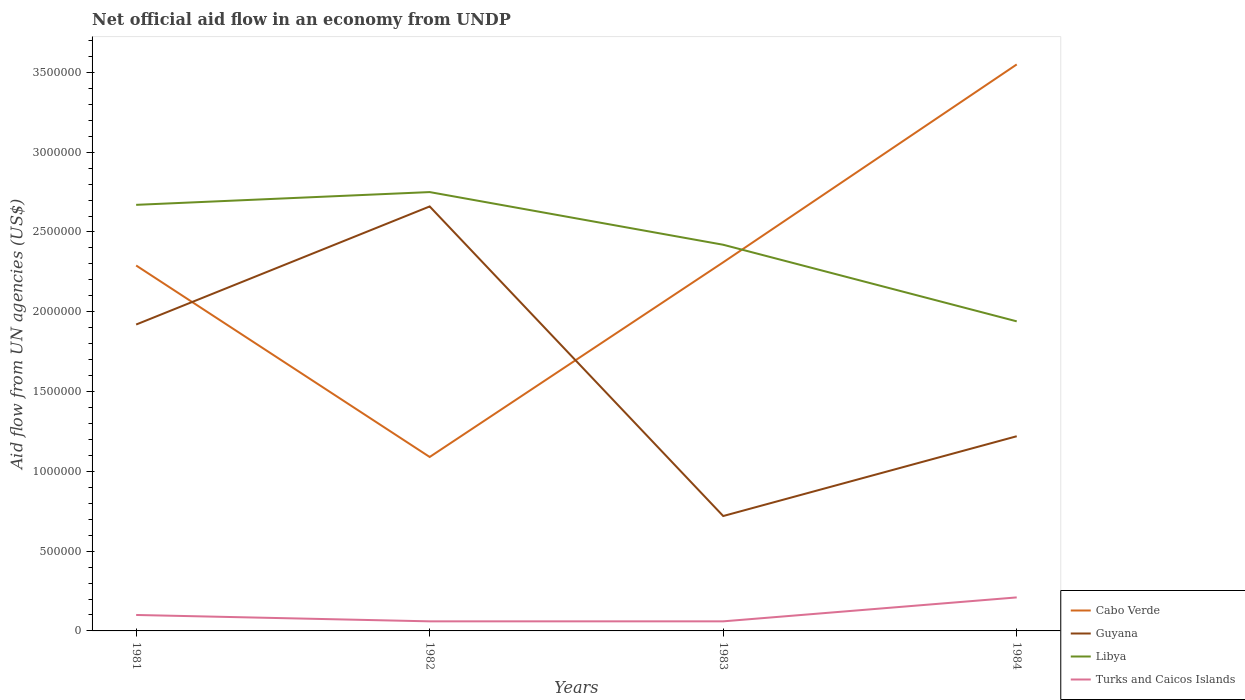How many different coloured lines are there?
Offer a very short reply. 4. In which year was the net official aid flow in Guyana maximum?
Your answer should be compact. 1983. What is the difference between the highest and the second highest net official aid flow in Libya?
Ensure brevity in your answer.  8.10e+05. Is the net official aid flow in Libya strictly greater than the net official aid flow in Cabo Verde over the years?
Make the answer very short. No. How many lines are there?
Make the answer very short. 4. What is the difference between two consecutive major ticks on the Y-axis?
Your response must be concise. 5.00e+05. Are the values on the major ticks of Y-axis written in scientific E-notation?
Provide a succinct answer. No. Where does the legend appear in the graph?
Provide a succinct answer. Bottom right. How are the legend labels stacked?
Ensure brevity in your answer.  Vertical. What is the title of the graph?
Offer a terse response. Net official aid flow in an economy from UNDP. What is the label or title of the Y-axis?
Your response must be concise. Aid flow from UN agencies (US$). What is the Aid flow from UN agencies (US$) in Cabo Verde in 1981?
Offer a very short reply. 2.29e+06. What is the Aid flow from UN agencies (US$) of Guyana in 1981?
Give a very brief answer. 1.92e+06. What is the Aid flow from UN agencies (US$) in Libya in 1981?
Your answer should be very brief. 2.67e+06. What is the Aid flow from UN agencies (US$) of Cabo Verde in 1982?
Offer a very short reply. 1.09e+06. What is the Aid flow from UN agencies (US$) in Guyana in 1982?
Make the answer very short. 2.66e+06. What is the Aid flow from UN agencies (US$) in Libya in 1982?
Your answer should be very brief. 2.75e+06. What is the Aid flow from UN agencies (US$) of Cabo Verde in 1983?
Give a very brief answer. 2.31e+06. What is the Aid flow from UN agencies (US$) in Guyana in 1983?
Your answer should be very brief. 7.20e+05. What is the Aid flow from UN agencies (US$) of Libya in 1983?
Your answer should be compact. 2.42e+06. What is the Aid flow from UN agencies (US$) in Turks and Caicos Islands in 1983?
Your answer should be compact. 6.00e+04. What is the Aid flow from UN agencies (US$) of Cabo Verde in 1984?
Keep it short and to the point. 3.55e+06. What is the Aid flow from UN agencies (US$) in Guyana in 1984?
Provide a succinct answer. 1.22e+06. What is the Aid flow from UN agencies (US$) in Libya in 1984?
Your answer should be very brief. 1.94e+06. Across all years, what is the maximum Aid flow from UN agencies (US$) in Cabo Verde?
Give a very brief answer. 3.55e+06. Across all years, what is the maximum Aid flow from UN agencies (US$) of Guyana?
Your response must be concise. 2.66e+06. Across all years, what is the maximum Aid flow from UN agencies (US$) in Libya?
Keep it short and to the point. 2.75e+06. Across all years, what is the minimum Aid flow from UN agencies (US$) of Cabo Verde?
Offer a very short reply. 1.09e+06. Across all years, what is the minimum Aid flow from UN agencies (US$) of Guyana?
Your response must be concise. 7.20e+05. Across all years, what is the minimum Aid flow from UN agencies (US$) in Libya?
Offer a terse response. 1.94e+06. Across all years, what is the minimum Aid flow from UN agencies (US$) of Turks and Caicos Islands?
Your response must be concise. 6.00e+04. What is the total Aid flow from UN agencies (US$) in Cabo Verde in the graph?
Provide a succinct answer. 9.24e+06. What is the total Aid flow from UN agencies (US$) in Guyana in the graph?
Ensure brevity in your answer.  6.52e+06. What is the total Aid flow from UN agencies (US$) in Libya in the graph?
Your answer should be compact. 9.78e+06. What is the difference between the Aid flow from UN agencies (US$) of Cabo Verde in 1981 and that in 1982?
Keep it short and to the point. 1.20e+06. What is the difference between the Aid flow from UN agencies (US$) in Guyana in 1981 and that in 1982?
Your answer should be compact. -7.40e+05. What is the difference between the Aid flow from UN agencies (US$) of Libya in 1981 and that in 1982?
Your answer should be compact. -8.00e+04. What is the difference between the Aid flow from UN agencies (US$) in Turks and Caicos Islands in 1981 and that in 1982?
Offer a very short reply. 4.00e+04. What is the difference between the Aid flow from UN agencies (US$) in Guyana in 1981 and that in 1983?
Make the answer very short. 1.20e+06. What is the difference between the Aid flow from UN agencies (US$) of Libya in 1981 and that in 1983?
Your response must be concise. 2.50e+05. What is the difference between the Aid flow from UN agencies (US$) of Cabo Verde in 1981 and that in 1984?
Offer a terse response. -1.26e+06. What is the difference between the Aid flow from UN agencies (US$) of Libya in 1981 and that in 1984?
Make the answer very short. 7.30e+05. What is the difference between the Aid flow from UN agencies (US$) in Turks and Caicos Islands in 1981 and that in 1984?
Ensure brevity in your answer.  -1.10e+05. What is the difference between the Aid flow from UN agencies (US$) of Cabo Verde in 1982 and that in 1983?
Offer a terse response. -1.22e+06. What is the difference between the Aid flow from UN agencies (US$) of Guyana in 1982 and that in 1983?
Your answer should be compact. 1.94e+06. What is the difference between the Aid flow from UN agencies (US$) of Turks and Caicos Islands in 1982 and that in 1983?
Offer a very short reply. 0. What is the difference between the Aid flow from UN agencies (US$) of Cabo Verde in 1982 and that in 1984?
Your answer should be very brief. -2.46e+06. What is the difference between the Aid flow from UN agencies (US$) of Guyana in 1982 and that in 1984?
Your answer should be compact. 1.44e+06. What is the difference between the Aid flow from UN agencies (US$) in Libya in 1982 and that in 1984?
Your answer should be very brief. 8.10e+05. What is the difference between the Aid flow from UN agencies (US$) in Cabo Verde in 1983 and that in 1984?
Offer a terse response. -1.24e+06. What is the difference between the Aid flow from UN agencies (US$) in Guyana in 1983 and that in 1984?
Your answer should be very brief. -5.00e+05. What is the difference between the Aid flow from UN agencies (US$) in Libya in 1983 and that in 1984?
Ensure brevity in your answer.  4.80e+05. What is the difference between the Aid flow from UN agencies (US$) of Turks and Caicos Islands in 1983 and that in 1984?
Make the answer very short. -1.50e+05. What is the difference between the Aid flow from UN agencies (US$) in Cabo Verde in 1981 and the Aid flow from UN agencies (US$) in Guyana in 1982?
Your answer should be compact. -3.70e+05. What is the difference between the Aid flow from UN agencies (US$) of Cabo Verde in 1981 and the Aid flow from UN agencies (US$) of Libya in 1982?
Give a very brief answer. -4.60e+05. What is the difference between the Aid flow from UN agencies (US$) of Cabo Verde in 1981 and the Aid flow from UN agencies (US$) of Turks and Caicos Islands in 1982?
Offer a very short reply. 2.23e+06. What is the difference between the Aid flow from UN agencies (US$) of Guyana in 1981 and the Aid flow from UN agencies (US$) of Libya in 1982?
Give a very brief answer. -8.30e+05. What is the difference between the Aid flow from UN agencies (US$) in Guyana in 1981 and the Aid flow from UN agencies (US$) in Turks and Caicos Islands in 1982?
Offer a very short reply. 1.86e+06. What is the difference between the Aid flow from UN agencies (US$) in Libya in 1981 and the Aid flow from UN agencies (US$) in Turks and Caicos Islands in 1982?
Offer a terse response. 2.61e+06. What is the difference between the Aid flow from UN agencies (US$) of Cabo Verde in 1981 and the Aid flow from UN agencies (US$) of Guyana in 1983?
Make the answer very short. 1.57e+06. What is the difference between the Aid flow from UN agencies (US$) of Cabo Verde in 1981 and the Aid flow from UN agencies (US$) of Turks and Caicos Islands in 1983?
Keep it short and to the point. 2.23e+06. What is the difference between the Aid flow from UN agencies (US$) in Guyana in 1981 and the Aid flow from UN agencies (US$) in Libya in 1983?
Your answer should be very brief. -5.00e+05. What is the difference between the Aid flow from UN agencies (US$) in Guyana in 1981 and the Aid flow from UN agencies (US$) in Turks and Caicos Islands in 1983?
Make the answer very short. 1.86e+06. What is the difference between the Aid flow from UN agencies (US$) in Libya in 1981 and the Aid flow from UN agencies (US$) in Turks and Caicos Islands in 1983?
Give a very brief answer. 2.61e+06. What is the difference between the Aid flow from UN agencies (US$) in Cabo Verde in 1981 and the Aid flow from UN agencies (US$) in Guyana in 1984?
Offer a very short reply. 1.07e+06. What is the difference between the Aid flow from UN agencies (US$) of Cabo Verde in 1981 and the Aid flow from UN agencies (US$) of Libya in 1984?
Make the answer very short. 3.50e+05. What is the difference between the Aid flow from UN agencies (US$) of Cabo Verde in 1981 and the Aid flow from UN agencies (US$) of Turks and Caicos Islands in 1984?
Keep it short and to the point. 2.08e+06. What is the difference between the Aid flow from UN agencies (US$) of Guyana in 1981 and the Aid flow from UN agencies (US$) of Libya in 1984?
Keep it short and to the point. -2.00e+04. What is the difference between the Aid flow from UN agencies (US$) of Guyana in 1981 and the Aid flow from UN agencies (US$) of Turks and Caicos Islands in 1984?
Make the answer very short. 1.71e+06. What is the difference between the Aid flow from UN agencies (US$) of Libya in 1981 and the Aid flow from UN agencies (US$) of Turks and Caicos Islands in 1984?
Make the answer very short. 2.46e+06. What is the difference between the Aid flow from UN agencies (US$) in Cabo Verde in 1982 and the Aid flow from UN agencies (US$) in Libya in 1983?
Your response must be concise. -1.33e+06. What is the difference between the Aid flow from UN agencies (US$) of Cabo Verde in 1982 and the Aid flow from UN agencies (US$) of Turks and Caicos Islands in 1983?
Your answer should be compact. 1.03e+06. What is the difference between the Aid flow from UN agencies (US$) in Guyana in 1982 and the Aid flow from UN agencies (US$) in Libya in 1983?
Provide a succinct answer. 2.40e+05. What is the difference between the Aid flow from UN agencies (US$) in Guyana in 1982 and the Aid flow from UN agencies (US$) in Turks and Caicos Islands in 1983?
Your answer should be very brief. 2.60e+06. What is the difference between the Aid flow from UN agencies (US$) of Libya in 1982 and the Aid flow from UN agencies (US$) of Turks and Caicos Islands in 1983?
Offer a terse response. 2.69e+06. What is the difference between the Aid flow from UN agencies (US$) of Cabo Verde in 1982 and the Aid flow from UN agencies (US$) of Libya in 1984?
Your answer should be very brief. -8.50e+05. What is the difference between the Aid flow from UN agencies (US$) in Cabo Verde in 1982 and the Aid flow from UN agencies (US$) in Turks and Caicos Islands in 1984?
Provide a short and direct response. 8.80e+05. What is the difference between the Aid flow from UN agencies (US$) in Guyana in 1982 and the Aid flow from UN agencies (US$) in Libya in 1984?
Your answer should be very brief. 7.20e+05. What is the difference between the Aid flow from UN agencies (US$) of Guyana in 1982 and the Aid flow from UN agencies (US$) of Turks and Caicos Islands in 1984?
Your answer should be very brief. 2.45e+06. What is the difference between the Aid flow from UN agencies (US$) of Libya in 1982 and the Aid flow from UN agencies (US$) of Turks and Caicos Islands in 1984?
Offer a terse response. 2.54e+06. What is the difference between the Aid flow from UN agencies (US$) of Cabo Verde in 1983 and the Aid flow from UN agencies (US$) of Guyana in 1984?
Your response must be concise. 1.09e+06. What is the difference between the Aid flow from UN agencies (US$) of Cabo Verde in 1983 and the Aid flow from UN agencies (US$) of Libya in 1984?
Provide a succinct answer. 3.70e+05. What is the difference between the Aid flow from UN agencies (US$) in Cabo Verde in 1983 and the Aid flow from UN agencies (US$) in Turks and Caicos Islands in 1984?
Offer a very short reply. 2.10e+06. What is the difference between the Aid flow from UN agencies (US$) of Guyana in 1983 and the Aid flow from UN agencies (US$) of Libya in 1984?
Your answer should be compact. -1.22e+06. What is the difference between the Aid flow from UN agencies (US$) in Guyana in 1983 and the Aid flow from UN agencies (US$) in Turks and Caicos Islands in 1984?
Give a very brief answer. 5.10e+05. What is the difference between the Aid flow from UN agencies (US$) of Libya in 1983 and the Aid flow from UN agencies (US$) of Turks and Caicos Islands in 1984?
Make the answer very short. 2.21e+06. What is the average Aid flow from UN agencies (US$) in Cabo Verde per year?
Provide a short and direct response. 2.31e+06. What is the average Aid flow from UN agencies (US$) in Guyana per year?
Your answer should be compact. 1.63e+06. What is the average Aid flow from UN agencies (US$) in Libya per year?
Offer a very short reply. 2.44e+06. What is the average Aid flow from UN agencies (US$) of Turks and Caicos Islands per year?
Your answer should be very brief. 1.08e+05. In the year 1981, what is the difference between the Aid flow from UN agencies (US$) in Cabo Verde and Aid flow from UN agencies (US$) in Guyana?
Your response must be concise. 3.70e+05. In the year 1981, what is the difference between the Aid flow from UN agencies (US$) of Cabo Verde and Aid flow from UN agencies (US$) of Libya?
Your answer should be very brief. -3.80e+05. In the year 1981, what is the difference between the Aid flow from UN agencies (US$) in Cabo Verde and Aid flow from UN agencies (US$) in Turks and Caicos Islands?
Your response must be concise. 2.19e+06. In the year 1981, what is the difference between the Aid flow from UN agencies (US$) of Guyana and Aid flow from UN agencies (US$) of Libya?
Provide a short and direct response. -7.50e+05. In the year 1981, what is the difference between the Aid flow from UN agencies (US$) of Guyana and Aid flow from UN agencies (US$) of Turks and Caicos Islands?
Offer a very short reply. 1.82e+06. In the year 1981, what is the difference between the Aid flow from UN agencies (US$) of Libya and Aid flow from UN agencies (US$) of Turks and Caicos Islands?
Offer a very short reply. 2.57e+06. In the year 1982, what is the difference between the Aid flow from UN agencies (US$) of Cabo Verde and Aid flow from UN agencies (US$) of Guyana?
Your answer should be very brief. -1.57e+06. In the year 1982, what is the difference between the Aid flow from UN agencies (US$) in Cabo Verde and Aid flow from UN agencies (US$) in Libya?
Offer a very short reply. -1.66e+06. In the year 1982, what is the difference between the Aid flow from UN agencies (US$) of Cabo Verde and Aid flow from UN agencies (US$) of Turks and Caicos Islands?
Make the answer very short. 1.03e+06. In the year 1982, what is the difference between the Aid flow from UN agencies (US$) of Guyana and Aid flow from UN agencies (US$) of Libya?
Provide a succinct answer. -9.00e+04. In the year 1982, what is the difference between the Aid flow from UN agencies (US$) in Guyana and Aid flow from UN agencies (US$) in Turks and Caicos Islands?
Ensure brevity in your answer.  2.60e+06. In the year 1982, what is the difference between the Aid flow from UN agencies (US$) in Libya and Aid flow from UN agencies (US$) in Turks and Caicos Islands?
Your answer should be compact. 2.69e+06. In the year 1983, what is the difference between the Aid flow from UN agencies (US$) of Cabo Verde and Aid flow from UN agencies (US$) of Guyana?
Provide a short and direct response. 1.59e+06. In the year 1983, what is the difference between the Aid flow from UN agencies (US$) of Cabo Verde and Aid flow from UN agencies (US$) of Turks and Caicos Islands?
Provide a succinct answer. 2.25e+06. In the year 1983, what is the difference between the Aid flow from UN agencies (US$) of Guyana and Aid flow from UN agencies (US$) of Libya?
Provide a short and direct response. -1.70e+06. In the year 1983, what is the difference between the Aid flow from UN agencies (US$) of Libya and Aid flow from UN agencies (US$) of Turks and Caicos Islands?
Make the answer very short. 2.36e+06. In the year 1984, what is the difference between the Aid flow from UN agencies (US$) of Cabo Verde and Aid flow from UN agencies (US$) of Guyana?
Your response must be concise. 2.33e+06. In the year 1984, what is the difference between the Aid flow from UN agencies (US$) in Cabo Verde and Aid flow from UN agencies (US$) in Libya?
Offer a terse response. 1.61e+06. In the year 1984, what is the difference between the Aid flow from UN agencies (US$) in Cabo Verde and Aid flow from UN agencies (US$) in Turks and Caicos Islands?
Keep it short and to the point. 3.34e+06. In the year 1984, what is the difference between the Aid flow from UN agencies (US$) of Guyana and Aid flow from UN agencies (US$) of Libya?
Keep it short and to the point. -7.20e+05. In the year 1984, what is the difference between the Aid flow from UN agencies (US$) in Guyana and Aid flow from UN agencies (US$) in Turks and Caicos Islands?
Keep it short and to the point. 1.01e+06. In the year 1984, what is the difference between the Aid flow from UN agencies (US$) of Libya and Aid flow from UN agencies (US$) of Turks and Caicos Islands?
Your response must be concise. 1.73e+06. What is the ratio of the Aid flow from UN agencies (US$) of Cabo Verde in 1981 to that in 1982?
Provide a short and direct response. 2.1. What is the ratio of the Aid flow from UN agencies (US$) in Guyana in 1981 to that in 1982?
Your response must be concise. 0.72. What is the ratio of the Aid flow from UN agencies (US$) in Libya in 1981 to that in 1982?
Your response must be concise. 0.97. What is the ratio of the Aid flow from UN agencies (US$) in Turks and Caicos Islands in 1981 to that in 1982?
Your response must be concise. 1.67. What is the ratio of the Aid flow from UN agencies (US$) in Cabo Verde in 1981 to that in 1983?
Provide a succinct answer. 0.99. What is the ratio of the Aid flow from UN agencies (US$) in Guyana in 1981 to that in 1983?
Provide a succinct answer. 2.67. What is the ratio of the Aid flow from UN agencies (US$) in Libya in 1981 to that in 1983?
Offer a very short reply. 1.1. What is the ratio of the Aid flow from UN agencies (US$) of Turks and Caicos Islands in 1981 to that in 1983?
Offer a terse response. 1.67. What is the ratio of the Aid flow from UN agencies (US$) of Cabo Verde in 1981 to that in 1984?
Your answer should be very brief. 0.65. What is the ratio of the Aid flow from UN agencies (US$) of Guyana in 1981 to that in 1984?
Make the answer very short. 1.57. What is the ratio of the Aid flow from UN agencies (US$) of Libya in 1981 to that in 1984?
Offer a terse response. 1.38. What is the ratio of the Aid flow from UN agencies (US$) of Turks and Caicos Islands in 1981 to that in 1984?
Your answer should be compact. 0.48. What is the ratio of the Aid flow from UN agencies (US$) of Cabo Verde in 1982 to that in 1983?
Your answer should be compact. 0.47. What is the ratio of the Aid flow from UN agencies (US$) in Guyana in 1982 to that in 1983?
Your answer should be very brief. 3.69. What is the ratio of the Aid flow from UN agencies (US$) in Libya in 1982 to that in 1983?
Your answer should be compact. 1.14. What is the ratio of the Aid flow from UN agencies (US$) in Turks and Caicos Islands in 1982 to that in 1983?
Provide a short and direct response. 1. What is the ratio of the Aid flow from UN agencies (US$) of Cabo Verde in 1982 to that in 1984?
Offer a terse response. 0.31. What is the ratio of the Aid flow from UN agencies (US$) in Guyana in 1982 to that in 1984?
Keep it short and to the point. 2.18. What is the ratio of the Aid flow from UN agencies (US$) in Libya in 1982 to that in 1984?
Your answer should be compact. 1.42. What is the ratio of the Aid flow from UN agencies (US$) of Turks and Caicos Islands in 1982 to that in 1984?
Your answer should be very brief. 0.29. What is the ratio of the Aid flow from UN agencies (US$) of Cabo Verde in 1983 to that in 1984?
Give a very brief answer. 0.65. What is the ratio of the Aid flow from UN agencies (US$) of Guyana in 1983 to that in 1984?
Provide a short and direct response. 0.59. What is the ratio of the Aid flow from UN agencies (US$) of Libya in 1983 to that in 1984?
Provide a short and direct response. 1.25. What is the ratio of the Aid flow from UN agencies (US$) of Turks and Caicos Islands in 1983 to that in 1984?
Your answer should be compact. 0.29. What is the difference between the highest and the second highest Aid flow from UN agencies (US$) of Cabo Verde?
Your answer should be compact. 1.24e+06. What is the difference between the highest and the second highest Aid flow from UN agencies (US$) of Guyana?
Offer a terse response. 7.40e+05. What is the difference between the highest and the second highest Aid flow from UN agencies (US$) in Libya?
Your answer should be compact. 8.00e+04. What is the difference between the highest and the second highest Aid flow from UN agencies (US$) in Turks and Caicos Islands?
Offer a very short reply. 1.10e+05. What is the difference between the highest and the lowest Aid flow from UN agencies (US$) in Cabo Verde?
Provide a succinct answer. 2.46e+06. What is the difference between the highest and the lowest Aid flow from UN agencies (US$) in Guyana?
Your answer should be compact. 1.94e+06. What is the difference between the highest and the lowest Aid flow from UN agencies (US$) of Libya?
Make the answer very short. 8.10e+05. 